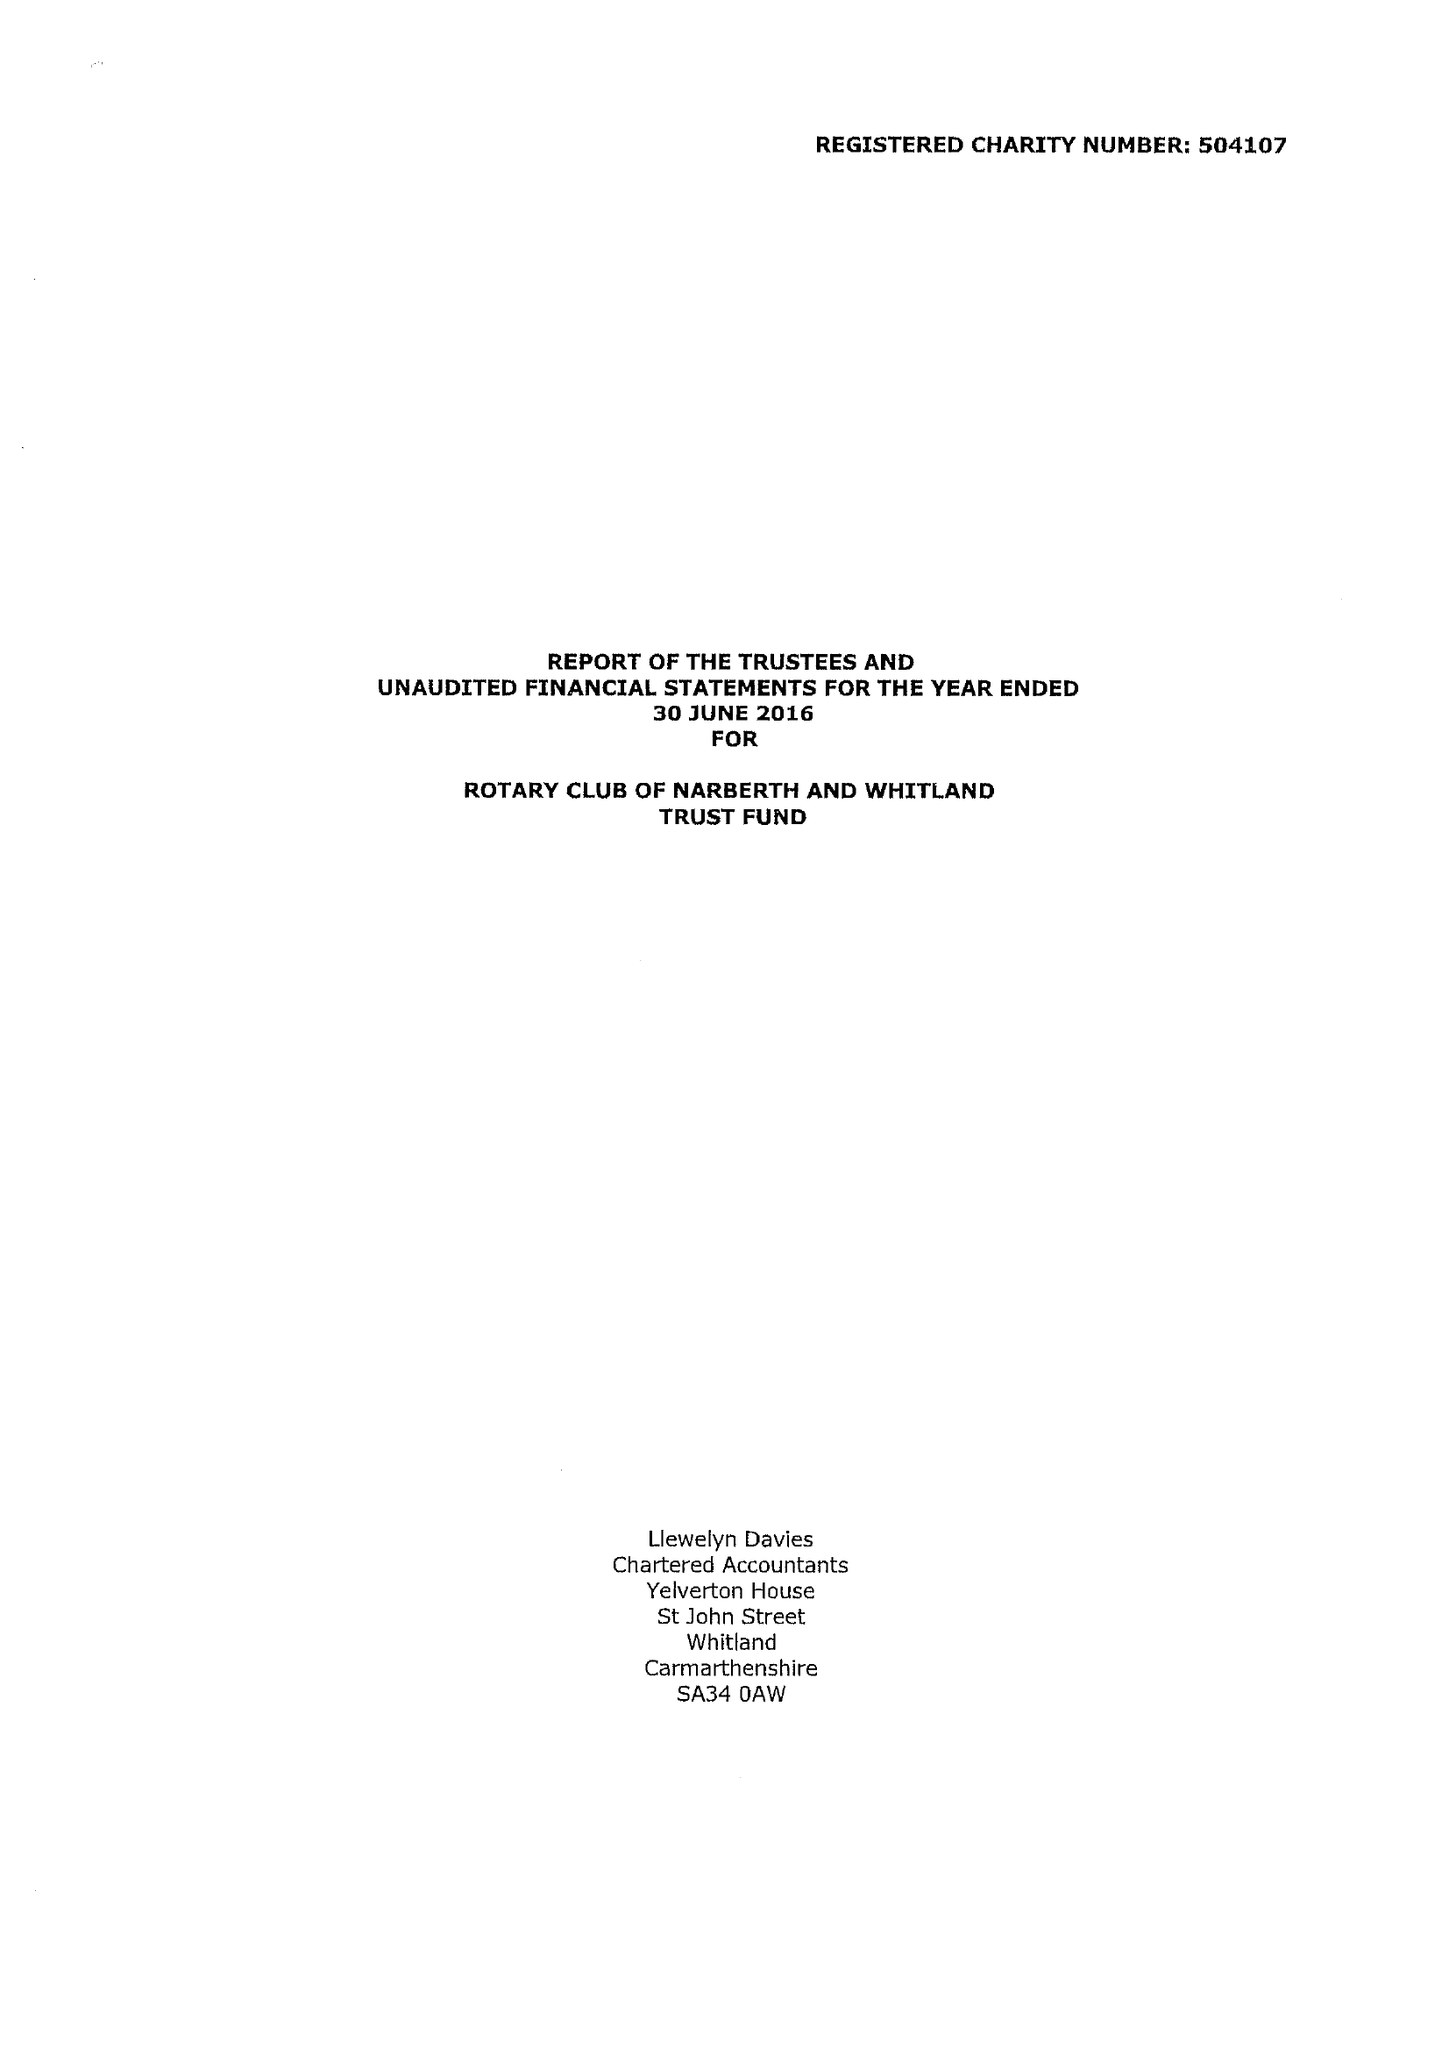What is the value for the address__street_line?
Answer the question using a single word or phrase. None 